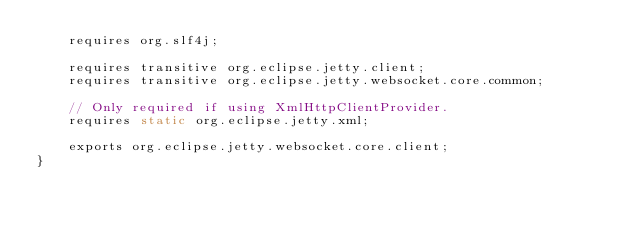<code> <loc_0><loc_0><loc_500><loc_500><_Java_>    requires org.slf4j;

    requires transitive org.eclipse.jetty.client;
    requires transitive org.eclipse.jetty.websocket.core.common;

    // Only required if using XmlHttpClientProvider.
    requires static org.eclipse.jetty.xml;

    exports org.eclipse.jetty.websocket.core.client;
}
</code> 